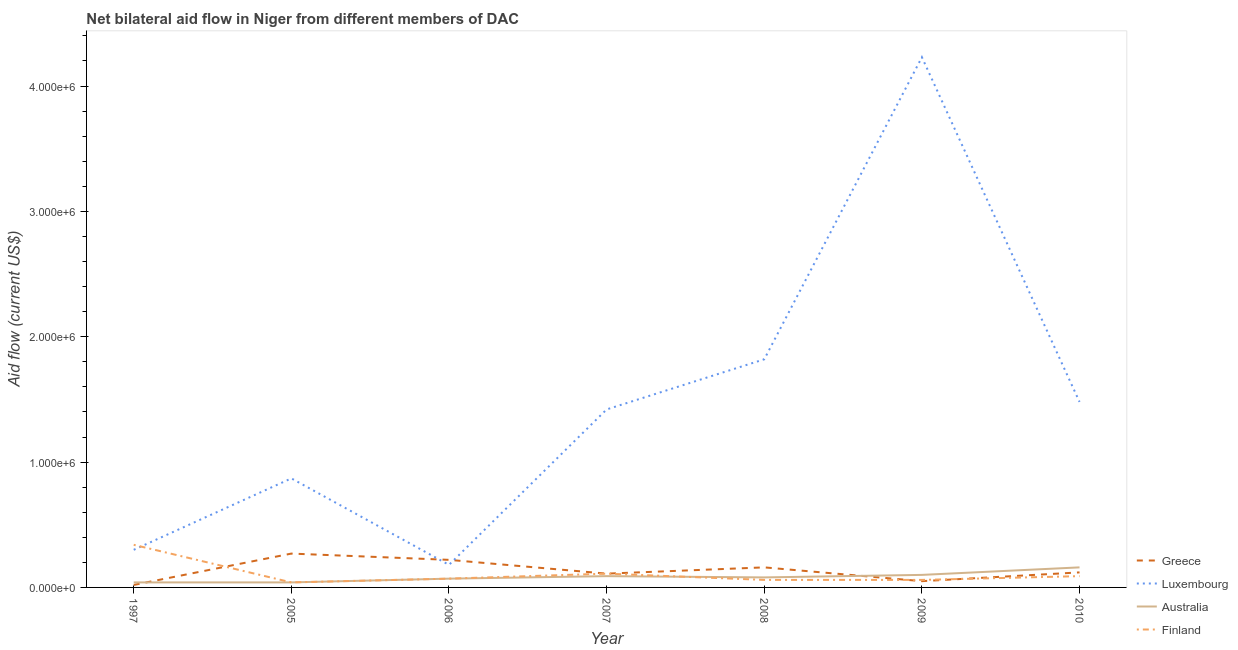How many different coloured lines are there?
Your answer should be very brief. 4. Does the line corresponding to amount of aid given by luxembourg intersect with the line corresponding to amount of aid given by greece?
Ensure brevity in your answer.  Yes. What is the amount of aid given by australia in 2005?
Keep it short and to the point. 4.00e+04. Across all years, what is the maximum amount of aid given by finland?
Your answer should be compact. 3.40e+05. Across all years, what is the minimum amount of aid given by australia?
Ensure brevity in your answer.  4.00e+04. In which year was the amount of aid given by luxembourg minimum?
Offer a terse response. 2006. What is the total amount of aid given by luxembourg in the graph?
Your response must be concise. 1.03e+07. What is the difference between the amount of aid given by luxembourg in 2005 and that in 2010?
Provide a short and direct response. -6.10e+05. What is the difference between the amount of aid given by australia in 2007 and the amount of aid given by finland in 2005?
Ensure brevity in your answer.  5.00e+04. What is the average amount of aid given by greece per year?
Ensure brevity in your answer.  1.36e+05. In the year 2010, what is the difference between the amount of aid given by luxembourg and amount of aid given by greece?
Your answer should be compact. 1.36e+06. In how many years, is the amount of aid given by luxembourg greater than 2400000 US$?
Provide a short and direct response. 1. What is the ratio of the amount of aid given by finland in 2007 to that in 2008?
Give a very brief answer. 1.83. Is the amount of aid given by greece in 2008 less than that in 2010?
Ensure brevity in your answer.  No. What is the difference between the highest and the lowest amount of aid given by australia?
Make the answer very short. 1.20e+05. In how many years, is the amount of aid given by greece greater than the average amount of aid given by greece taken over all years?
Offer a terse response. 3. Is the sum of the amount of aid given by luxembourg in 2006 and 2008 greater than the maximum amount of aid given by australia across all years?
Provide a short and direct response. Yes. Is it the case that in every year, the sum of the amount of aid given by greece and amount of aid given by luxembourg is greater than the amount of aid given by australia?
Your response must be concise. Yes. Is the amount of aid given by australia strictly greater than the amount of aid given by finland over the years?
Give a very brief answer. No. How many years are there in the graph?
Give a very brief answer. 7. What is the difference between two consecutive major ticks on the Y-axis?
Give a very brief answer. 1.00e+06. How are the legend labels stacked?
Your answer should be compact. Vertical. What is the title of the graph?
Provide a short and direct response. Net bilateral aid flow in Niger from different members of DAC. Does "Greece" appear as one of the legend labels in the graph?
Give a very brief answer. Yes. What is the Aid flow (current US$) in Luxembourg in 1997?
Give a very brief answer. 3.00e+05. What is the Aid flow (current US$) in Greece in 2005?
Your answer should be very brief. 2.70e+05. What is the Aid flow (current US$) in Luxembourg in 2005?
Keep it short and to the point. 8.70e+05. What is the Aid flow (current US$) of Australia in 2005?
Give a very brief answer. 4.00e+04. What is the Aid flow (current US$) of Australia in 2006?
Offer a terse response. 7.00e+04. What is the Aid flow (current US$) in Finland in 2006?
Ensure brevity in your answer.  7.00e+04. What is the Aid flow (current US$) in Greece in 2007?
Offer a very short reply. 1.10e+05. What is the Aid flow (current US$) in Luxembourg in 2007?
Provide a short and direct response. 1.42e+06. What is the Aid flow (current US$) in Greece in 2008?
Keep it short and to the point. 1.60e+05. What is the Aid flow (current US$) in Luxembourg in 2008?
Keep it short and to the point. 1.82e+06. What is the Aid flow (current US$) of Australia in 2008?
Keep it short and to the point. 8.00e+04. What is the Aid flow (current US$) in Finland in 2008?
Your response must be concise. 6.00e+04. What is the Aid flow (current US$) in Greece in 2009?
Give a very brief answer. 5.00e+04. What is the Aid flow (current US$) in Luxembourg in 2009?
Provide a succinct answer. 4.23e+06. What is the Aid flow (current US$) in Australia in 2009?
Your response must be concise. 1.00e+05. What is the Aid flow (current US$) of Finland in 2009?
Offer a terse response. 6.00e+04. What is the Aid flow (current US$) of Greece in 2010?
Give a very brief answer. 1.20e+05. What is the Aid flow (current US$) of Luxembourg in 2010?
Offer a terse response. 1.48e+06. Across all years, what is the maximum Aid flow (current US$) of Greece?
Your answer should be very brief. 2.70e+05. Across all years, what is the maximum Aid flow (current US$) of Luxembourg?
Your response must be concise. 4.23e+06. Across all years, what is the maximum Aid flow (current US$) in Australia?
Ensure brevity in your answer.  1.60e+05. Across all years, what is the minimum Aid flow (current US$) of Luxembourg?
Keep it short and to the point. 1.80e+05. What is the total Aid flow (current US$) in Greece in the graph?
Make the answer very short. 9.50e+05. What is the total Aid flow (current US$) of Luxembourg in the graph?
Your response must be concise. 1.03e+07. What is the total Aid flow (current US$) of Australia in the graph?
Ensure brevity in your answer.  5.80e+05. What is the total Aid flow (current US$) in Finland in the graph?
Give a very brief answer. 7.70e+05. What is the difference between the Aid flow (current US$) in Luxembourg in 1997 and that in 2005?
Make the answer very short. -5.70e+05. What is the difference between the Aid flow (current US$) of Australia in 1997 and that in 2005?
Give a very brief answer. 0. What is the difference between the Aid flow (current US$) in Finland in 1997 and that in 2005?
Offer a terse response. 3.00e+05. What is the difference between the Aid flow (current US$) in Australia in 1997 and that in 2006?
Offer a very short reply. -3.00e+04. What is the difference between the Aid flow (current US$) in Finland in 1997 and that in 2006?
Offer a very short reply. 2.70e+05. What is the difference between the Aid flow (current US$) of Greece in 1997 and that in 2007?
Your response must be concise. -9.00e+04. What is the difference between the Aid flow (current US$) of Luxembourg in 1997 and that in 2007?
Offer a terse response. -1.12e+06. What is the difference between the Aid flow (current US$) in Finland in 1997 and that in 2007?
Offer a very short reply. 2.30e+05. What is the difference between the Aid flow (current US$) of Greece in 1997 and that in 2008?
Provide a succinct answer. -1.40e+05. What is the difference between the Aid flow (current US$) in Luxembourg in 1997 and that in 2008?
Give a very brief answer. -1.52e+06. What is the difference between the Aid flow (current US$) of Australia in 1997 and that in 2008?
Your response must be concise. -4.00e+04. What is the difference between the Aid flow (current US$) in Finland in 1997 and that in 2008?
Give a very brief answer. 2.80e+05. What is the difference between the Aid flow (current US$) of Greece in 1997 and that in 2009?
Offer a very short reply. -3.00e+04. What is the difference between the Aid flow (current US$) in Luxembourg in 1997 and that in 2009?
Provide a succinct answer. -3.93e+06. What is the difference between the Aid flow (current US$) of Australia in 1997 and that in 2009?
Offer a terse response. -6.00e+04. What is the difference between the Aid flow (current US$) in Finland in 1997 and that in 2009?
Your answer should be compact. 2.80e+05. What is the difference between the Aid flow (current US$) in Greece in 1997 and that in 2010?
Offer a terse response. -1.00e+05. What is the difference between the Aid flow (current US$) of Luxembourg in 1997 and that in 2010?
Your answer should be very brief. -1.18e+06. What is the difference between the Aid flow (current US$) of Greece in 2005 and that in 2006?
Your response must be concise. 5.00e+04. What is the difference between the Aid flow (current US$) in Luxembourg in 2005 and that in 2006?
Your response must be concise. 6.90e+05. What is the difference between the Aid flow (current US$) in Luxembourg in 2005 and that in 2007?
Offer a very short reply. -5.50e+05. What is the difference between the Aid flow (current US$) in Greece in 2005 and that in 2008?
Make the answer very short. 1.10e+05. What is the difference between the Aid flow (current US$) of Luxembourg in 2005 and that in 2008?
Provide a short and direct response. -9.50e+05. What is the difference between the Aid flow (current US$) in Greece in 2005 and that in 2009?
Keep it short and to the point. 2.20e+05. What is the difference between the Aid flow (current US$) in Luxembourg in 2005 and that in 2009?
Provide a short and direct response. -3.36e+06. What is the difference between the Aid flow (current US$) of Greece in 2005 and that in 2010?
Give a very brief answer. 1.50e+05. What is the difference between the Aid flow (current US$) of Luxembourg in 2005 and that in 2010?
Offer a terse response. -6.10e+05. What is the difference between the Aid flow (current US$) in Luxembourg in 2006 and that in 2007?
Your answer should be compact. -1.24e+06. What is the difference between the Aid flow (current US$) in Australia in 2006 and that in 2007?
Provide a succinct answer. -2.00e+04. What is the difference between the Aid flow (current US$) in Luxembourg in 2006 and that in 2008?
Your answer should be very brief. -1.64e+06. What is the difference between the Aid flow (current US$) in Finland in 2006 and that in 2008?
Your response must be concise. 10000. What is the difference between the Aid flow (current US$) in Greece in 2006 and that in 2009?
Make the answer very short. 1.70e+05. What is the difference between the Aid flow (current US$) in Luxembourg in 2006 and that in 2009?
Give a very brief answer. -4.05e+06. What is the difference between the Aid flow (current US$) in Finland in 2006 and that in 2009?
Give a very brief answer. 10000. What is the difference between the Aid flow (current US$) of Greece in 2006 and that in 2010?
Make the answer very short. 1.00e+05. What is the difference between the Aid flow (current US$) in Luxembourg in 2006 and that in 2010?
Provide a short and direct response. -1.30e+06. What is the difference between the Aid flow (current US$) of Finland in 2006 and that in 2010?
Your response must be concise. -2.00e+04. What is the difference between the Aid flow (current US$) of Greece in 2007 and that in 2008?
Ensure brevity in your answer.  -5.00e+04. What is the difference between the Aid flow (current US$) of Luxembourg in 2007 and that in 2008?
Offer a terse response. -4.00e+05. What is the difference between the Aid flow (current US$) of Australia in 2007 and that in 2008?
Keep it short and to the point. 10000. What is the difference between the Aid flow (current US$) in Luxembourg in 2007 and that in 2009?
Ensure brevity in your answer.  -2.81e+06. What is the difference between the Aid flow (current US$) in Australia in 2007 and that in 2009?
Your answer should be compact. -10000. What is the difference between the Aid flow (current US$) of Greece in 2007 and that in 2010?
Your response must be concise. -10000. What is the difference between the Aid flow (current US$) in Luxembourg in 2007 and that in 2010?
Offer a very short reply. -6.00e+04. What is the difference between the Aid flow (current US$) of Luxembourg in 2008 and that in 2009?
Provide a succinct answer. -2.41e+06. What is the difference between the Aid flow (current US$) of Australia in 2008 and that in 2009?
Make the answer very short. -2.00e+04. What is the difference between the Aid flow (current US$) in Finland in 2008 and that in 2009?
Your answer should be compact. 0. What is the difference between the Aid flow (current US$) in Luxembourg in 2008 and that in 2010?
Your answer should be very brief. 3.40e+05. What is the difference between the Aid flow (current US$) in Finland in 2008 and that in 2010?
Your answer should be very brief. -3.00e+04. What is the difference between the Aid flow (current US$) in Greece in 2009 and that in 2010?
Ensure brevity in your answer.  -7.00e+04. What is the difference between the Aid flow (current US$) of Luxembourg in 2009 and that in 2010?
Your response must be concise. 2.75e+06. What is the difference between the Aid flow (current US$) in Greece in 1997 and the Aid flow (current US$) in Luxembourg in 2005?
Your response must be concise. -8.50e+05. What is the difference between the Aid flow (current US$) in Greece in 1997 and the Aid flow (current US$) in Finland in 2005?
Make the answer very short. -2.00e+04. What is the difference between the Aid flow (current US$) in Luxembourg in 1997 and the Aid flow (current US$) in Finland in 2005?
Make the answer very short. 2.60e+05. What is the difference between the Aid flow (current US$) of Australia in 1997 and the Aid flow (current US$) of Finland in 2005?
Provide a succinct answer. 0. What is the difference between the Aid flow (current US$) in Greece in 1997 and the Aid flow (current US$) in Finland in 2006?
Keep it short and to the point. -5.00e+04. What is the difference between the Aid flow (current US$) in Luxembourg in 1997 and the Aid flow (current US$) in Finland in 2006?
Provide a succinct answer. 2.30e+05. What is the difference between the Aid flow (current US$) of Australia in 1997 and the Aid flow (current US$) of Finland in 2006?
Offer a terse response. -3.00e+04. What is the difference between the Aid flow (current US$) of Greece in 1997 and the Aid flow (current US$) of Luxembourg in 2007?
Provide a succinct answer. -1.40e+06. What is the difference between the Aid flow (current US$) in Greece in 1997 and the Aid flow (current US$) in Finland in 2007?
Keep it short and to the point. -9.00e+04. What is the difference between the Aid flow (current US$) in Australia in 1997 and the Aid flow (current US$) in Finland in 2007?
Provide a short and direct response. -7.00e+04. What is the difference between the Aid flow (current US$) of Greece in 1997 and the Aid flow (current US$) of Luxembourg in 2008?
Ensure brevity in your answer.  -1.80e+06. What is the difference between the Aid flow (current US$) in Greece in 1997 and the Aid flow (current US$) in Australia in 2008?
Give a very brief answer. -6.00e+04. What is the difference between the Aid flow (current US$) in Greece in 1997 and the Aid flow (current US$) in Finland in 2008?
Provide a succinct answer. -4.00e+04. What is the difference between the Aid flow (current US$) of Luxembourg in 1997 and the Aid flow (current US$) of Australia in 2008?
Your response must be concise. 2.20e+05. What is the difference between the Aid flow (current US$) of Luxembourg in 1997 and the Aid flow (current US$) of Finland in 2008?
Give a very brief answer. 2.40e+05. What is the difference between the Aid flow (current US$) in Australia in 1997 and the Aid flow (current US$) in Finland in 2008?
Ensure brevity in your answer.  -2.00e+04. What is the difference between the Aid flow (current US$) of Greece in 1997 and the Aid flow (current US$) of Luxembourg in 2009?
Offer a terse response. -4.21e+06. What is the difference between the Aid flow (current US$) of Luxembourg in 1997 and the Aid flow (current US$) of Finland in 2009?
Make the answer very short. 2.40e+05. What is the difference between the Aid flow (current US$) of Australia in 1997 and the Aid flow (current US$) of Finland in 2009?
Give a very brief answer. -2.00e+04. What is the difference between the Aid flow (current US$) of Greece in 1997 and the Aid flow (current US$) of Luxembourg in 2010?
Your response must be concise. -1.46e+06. What is the difference between the Aid flow (current US$) of Greece in 1997 and the Aid flow (current US$) of Australia in 2010?
Give a very brief answer. -1.40e+05. What is the difference between the Aid flow (current US$) in Luxembourg in 1997 and the Aid flow (current US$) in Australia in 2010?
Your answer should be compact. 1.40e+05. What is the difference between the Aid flow (current US$) of Australia in 1997 and the Aid flow (current US$) of Finland in 2010?
Offer a very short reply. -5.00e+04. What is the difference between the Aid flow (current US$) in Greece in 2005 and the Aid flow (current US$) in Luxembourg in 2006?
Ensure brevity in your answer.  9.00e+04. What is the difference between the Aid flow (current US$) of Greece in 2005 and the Aid flow (current US$) of Luxembourg in 2007?
Your response must be concise. -1.15e+06. What is the difference between the Aid flow (current US$) of Greece in 2005 and the Aid flow (current US$) of Australia in 2007?
Your answer should be very brief. 1.80e+05. What is the difference between the Aid flow (current US$) in Greece in 2005 and the Aid flow (current US$) in Finland in 2007?
Offer a terse response. 1.60e+05. What is the difference between the Aid flow (current US$) of Luxembourg in 2005 and the Aid flow (current US$) of Australia in 2007?
Provide a succinct answer. 7.80e+05. What is the difference between the Aid flow (current US$) of Luxembourg in 2005 and the Aid flow (current US$) of Finland in 2007?
Your response must be concise. 7.60e+05. What is the difference between the Aid flow (current US$) of Greece in 2005 and the Aid flow (current US$) of Luxembourg in 2008?
Offer a very short reply. -1.55e+06. What is the difference between the Aid flow (current US$) in Greece in 2005 and the Aid flow (current US$) in Australia in 2008?
Make the answer very short. 1.90e+05. What is the difference between the Aid flow (current US$) in Luxembourg in 2005 and the Aid flow (current US$) in Australia in 2008?
Ensure brevity in your answer.  7.90e+05. What is the difference between the Aid flow (current US$) of Luxembourg in 2005 and the Aid flow (current US$) of Finland in 2008?
Offer a very short reply. 8.10e+05. What is the difference between the Aid flow (current US$) in Greece in 2005 and the Aid flow (current US$) in Luxembourg in 2009?
Offer a very short reply. -3.96e+06. What is the difference between the Aid flow (current US$) of Greece in 2005 and the Aid flow (current US$) of Australia in 2009?
Make the answer very short. 1.70e+05. What is the difference between the Aid flow (current US$) in Luxembourg in 2005 and the Aid flow (current US$) in Australia in 2009?
Provide a short and direct response. 7.70e+05. What is the difference between the Aid flow (current US$) in Luxembourg in 2005 and the Aid flow (current US$) in Finland in 2009?
Your answer should be very brief. 8.10e+05. What is the difference between the Aid flow (current US$) of Australia in 2005 and the Aid flow (current US$) of Finland in 2009?
Offer a very short reply. -2.00e+04. What is the difference between the Aid flow (current US$) of Greece in 2005 and the Aid flow (current US$) of Luxembourg in 2010?
Offer a terse response. -1.21e+06. What is the difference between the Aid flow (current US$) of Greece in 2005 and the Aid flow (current US$) of Australia in 2010?
Give a very brief answer. 1.10e+05. What is the difference between the Aid flow (current US$) of Greece in 2005 and the Aid flow (current US$) of Finland in 2010?
Offer a very short reply. 1.80e+05. What is the difference between the Aid flow (current US$) of Luxembourg in 2005 and the Aid flow (current US$) of Australia in 2010?
Offer a terse response. 7.10e+05. What is the difference between the Aid flow (current US$) in Luxembourg in 2005 and the Aid flow (current US$) in Finland in 2010?
Keep it short and to the point. 7.80e+05. What is the difference between the Aid flow (current US$) of Australia in 2005 and the Aid flow (current US$) of Finland in 2010?
Offer a very short reply. -5.00e+04. What is the difference between the Aid flow (current US$) in Greece in 2006 and the Aid flow (current US$) in Luxembourg in 2007?
Keep it short and to the point. -1.20e+06. What is the difference between the Aid flow (current US$) of Greece in 2006 and the Aid flow (current US$) of Luxembourg in 2008?
Your answer should be very brief. -1.60e+06. What is the difference between the Aid flow (current US$) of Luxembourg in 2006 and the Aid flow (current US$) of Australia in 2008?
Offer a terse response. 1.00e+05. What is the difference between the Aid flow (current US$) of Australia in 2006 and the Aid flow (current US$) of Finland in 2008?
Make the answer very short. 10000. What is the difference between the Aid flow (current US$) in Greece in 2006 and the Aid flow (current US$) in Luxembourg in 2009?
Ensure brevity in your answer.  -4.01e+06. What is the difference between the Aid flow (current US$) in Greece in 2006 and the Aid flow (current US$) in Australia in 2009?
Ensure brevity in your answer.  1.20e+05. What is the difference between the Aid flow (current US$) of Greece in 2006 and the Aid flow (current US$) of Luxembourg in 2010?
Offer a terse response. -1.26e+06. What is the difference between the Aid flow (current US$) of Greece in 2006 and the Aid flow (current US$) of Finland in 2010?
Your answer should be compact. 1.30e+05. What is the difference between the Aid flow (current US$) in Luxembourg in 2006 and the Aid flow (current US$) in Australia in 2010?
Provide a succinct answer. 2.00e+04. What is the difference between the Aid flow (current US$) of Greece in 2007 and the Aid flow (current US$) of Luxembourg in 2008?
Provide a short and direct response. -1.71e+06. What is the difference between the Aid flow (current US$) of Luxembourg in 2007 and the Aid flow (current US$) of Australia in 2008?
Ensure brevity in your answer.  1.34e+06. What is the difference between the Aid flow (current US$) in Luxembourg in 2007 and the Aid flow (current US$) in Finland in 2008?
Your answer should be compact. 1.36e+06. What is the difference between the Aid flow (current US$) in Australia in 2007 and the Aid flow (current US$) in Finland in 2008?
Provide a short and direct response. 3.00e+04. What is the difference between the Aid flow (current US$) of Greece in 2007 and the Aid flow (current US$) of Luxembourg in 2009?
Ensure brevity in your answer.  -4.12e+06. What is the difference between the Aid flow (current US$) in Greece in 2007 and the Aid flow (current US$) in Finland in 2009?
Your answer should be compact. 5.00e+04. What is the difference between the Aid flow (current US$) of Luxembourg in 2007 and the Aid flow (current US$) of Australia in 2009?
Make the answer very short. 1.32e+06. What is the difference between the Aid flow (current US$) in Luxembourg in 2007 and the Aid flow (current US$) in Finland in 2009?
Keep it short and to the point. 1.36e+06. What is the difference between the Aid flow (current US$) of Greece in 2007 and the Aid flow (current US$) of Luxembourg in 2010?
Keep it short and to the point. -1.37e+06. What is the difference between the Aid flow (current US$) of Greece in 2007 and the Aid flow (current US$) of Australia in 2010?
Provide a short and direct response. -5.00e+04. What is the difference between the Aid flow (current US$) in Greece in 2007 and the Aid flow (current US$) in Finland in 2010?
Offer a terse response. 2.00e+04. What is the difference between the Aid flow (current US$) in Luxembourg in 2007 and the Aid flow (current US$) in Australia in 2010?
Offer a very short reply. 1.26e+06. What is the difference between the Aid flow (current US$) in Luxembourg in 2007 and the Aid flow (current US$) in Finland in 2010?
Your answer should be compact. 1.33e+06. What is the difference between the Aid flow (current US$) of Australia in 2007 and the Aid flow (current US$) of Finland in 2010?
Your response must be concise. 0. What is the difference between the Aid flow (current US$) in Greece in 2008 and the Aid flow (current US$) in Luxembourg in 2009?
Offer a very short reply. -4.07e+06. What is the difference between the Aid flow (current US$) in Greece in 2008 and the Aid flow (current US$) in Finland in 2009?
Offer a terse response. 1.00e+05. What is the difference between the Aid flow (current US$) in Luxembourg in 2008 and the Aid flow (current US$) in Australia in 2009?
Provide a succinct answer. 1.72e+06. What is the difference between the Aid flow (current US$) in Luxembourg in 2008 and the Aid flow (current US$) in Finland in 2009?
Give a very brief answer. 1.76e+06. What is the difference between the Aid flow (current US$) of Australia in 2008 and the Aid flow (current US$) of Finland in 2009?
Provide a succinct answer. 2.00e+04. What is the difference between the Aid flow (current US$) in Greece in 2008 and the Aid flow (current US$) in Luxembourg in 2010?
Your answer should be compact. -1.32e+06. What is the difference between the Aid flow (current US$) of Greece in 2008 and the Aid flow (current US$) of Australia in 2010?
Your answer should be very brief. 0. What is the difference between the Aid flow (current US$) of Greece in 2008 and the Aid flow (current US$) of Finland in 2010?
Ensure brevity in your answer.  7.00e+04. What is the difference between the Aid flow (current US$) of Luxembourg in 2008 and the Aid flow (current US$) of Australia in 2010?
Provide a succinct answer. 1.66e+06. What is the difference between the Aid flow (current US$) of Luxembourg in 2008 and the Aid flow (current US$) of Finland in 2010?
Provide a short and direct response. 1.73e+06. What is the difference between the Aid flow (current US$) in Australia in 2008 and the Aid flow (current US$) in Finland in 2010?
Your answer should be compact. -10000. What is the difference between the Aid flow (current US$) in Greece in 2009 and the Aid flow (current US$) in Luxembourg in 2010?
Ensure brevity in your answer.  -1.43e+06. What is the difference between the Aid flow (current US$) in Greece in 2009 and the Aid flow (current US$) in Australia in 2010?
Give a very brief answer. -1.10e+05. What is the difference between the Aid flow (current US$) of Luxembourg in 2009 and the Aid flow (current US$) of Australia in 2010?
Your answer should be very brief. 4.07e+06. What is the difference between the Aid flow (current US$) in Luxembourg in 2009 and the Aid flow (current US$) in Finland in 2010?
Offer a very short reply. 4.14e+06. What is the difference between the Aid flow (current US$) in Australia in 2009 and the Aid flow (current US$) in Finland in 2010?
Ensure brevity in your answer.  10000. What is the average Aid flow (current US$) of Greece per year?
Your answer should be compact. 1.36e+05. What is the average Aid flow (current US$) in Luxembourg per year?
Ensure brevity in your answer.  1.47e+06. What is the average Aid flow (current US$) in Australia per year?
Your answer should be very brief. 8.29e+04. What is the average Aid flow (current US$) of Finland per year?
Your answer should be very brief. 1.10e+05. In the year 1997, what is the difference between the Aid flow (current US$) of Greece and Aid flow (current US$) of Luxembourg?
Keep it short and to the point. -2.80e+05. In the year 1997, what is the difference between the Aid flow (current US$) of Greece and Aid flow (current US$) of Australia?
Offer a very short reply. -2.00e+04. In the year 1997, what is the difference between the Aid flow (current US$) in Greece and Aid flow (current US$) in Finland?
Provide a succinct answer. -3.20e+05. In the year 2005, what is the difference between the Aid flow (current US$) of Greece and Aid flow (current US$) of Luxembourg?
Provide a short and direct response. -6.00e+05. In the year 2005, what is the difference between the Aid flow (current US$) in Greece and Aid flow (current US$) in Australia?
Offer a terse response. 2.30e+05. In the year 2005, what is the difference between the Aid flow (current US$) of Greece and Aid flow (current US$) of Finland?
Give a very brief answer. 2.30e+05. In the year 2005, what is the difference between the Aid flow (current US$) of Luxembourg and Aid flow (current US$) of Australia?
Your answer should be compact. 8.30e+05. In the year 2005, what is the difference between the Aid flow (current US$) of Luxembourg and Aid flow (current US$) of Finland?
Provide a succinct answer. 8.30e+05. In the year 2005, what is the difference between the Aid flow (current US$) in Australia and Aid flow (current US$) in Finland?
Provide a short and direct response. 0. In the year 2006, what is the difference between the Aid flow (current US$) in Greece and Aid flow (current US$) in Luxembourg?
Give a very brief answer. 4.00e+04. In the year 2006, what is the difference between the Aid flow (current US$) of Greece and Aid flow (current US$) of Australia?
Offer a terse response. 1.50e+05. In the year 2007, what is the difference between the Aid flow (current US$) of Greece and Aid flow (current US$) of Luxembourg?
Offer a terse response. -1.31e+06. In the year 2007, what is the difference between the Aid flow (current US$) in Greece and Aid flow (current US$) in Australia?
Offer a very short reply. 2.00e+04. In the year 2007, what is the difference between the Aid flow (current US$) in Greece and Aid flow (current US$) in Finland?
Offer a terse response. 0. In the year 2007, what is the difference between the Aid flow (current US$) in Luxembourg and Aid flow (current US$) in Australia?
Offer a terse response. 1.33e+06. In the year 2007, what is the difference between the Aid flow (current US$) in Luxembourg and Aid flow (current US$) in Finland?
Provide a succinct answer. 1.31e+06. In the year 2007, what is the difference between the Aid flow (current US$) in Australia and Aid flow (current US$) in Finland?
Your response must be concise. -2.00e+04. In the year 2008, what is the difference between the Aid flow (current US$) of Greece and Aid flow (current US$) of Luxembourg?
Your answer should be very brief. -1.66e+06. In the year 2008, what is the difference between the Aid flow (current US$) of Greece and Aid flow (current US$) of Australia?
Keep it short and to the point. 8.00e+04. In the year 2008, what is the difference between the Aid flow (current US$) of Greece and Aid flow (current US$) of Finland?
Keep it short and to the point. 1.00e+05. In the year 2008, what is the difference between the Aid flow (current US$) in Luxembourg and Aid flow (current US$) in Australia?
Your response must be concise. 1.74e+06. In the year 2008, what is the difference between the Aid flow (current US$) of Luxembourg and Aid flow (current US$) of Finland?
Make the answer very short. 1.76e+06. In the year 2009, what is the difference between the Aid flow (current US$) in Greece and Aid flow (current US$) in Luxembourg?
Ensure brevity in your answer.  -4.18e+06. In the year 2009, what is the difference between the Aid flow (current US$) in Luxembourg and Aid flow (current US$) in Australia?
Your answer should be compact. 4.13e+06. In the year 2009, what is the difference between the Aid flow (current US$) of Luxembourg and Aid flow (current US$) of Finland?
Your answer should be compact. 4.17e+06. In the year 2010, what is the difference between the Aid flow (current US$) in Greece and Aid flow (current US$) in Luxembourg?
Your response must be concise. -1.36e+06. In the year 2010, what is the difference between the Aid flow (current US$) in Greece and Aid flow (current US$) in Finland?
Offer a very short reply. 3.00e+04. In the year 2010, what is the difference between the Aid flow (current US$) in Luxembourg and Aid flow (current US$) in Australia?
Offer a terse response. 1.32e+06. In the year 2010, what is the difference between the Aid flow (current US$) of Luxembourg and Aid flow (current US$) of Finland?
Offer a terse response. 1.39e+06. What is the ratio of the Aid flow (current US$) of Greece in 1997 to that in 2005?
Your response must be concise. 0.07. What is the ratio of the Aid flow (current US$) in Luxembourg in 1997 to that in 2005?
Make the answer very short. 0.34. What is the ratio of the Aid flow (current US$) in Finland in 1997 to that in 2005?
Ensure brevity in your answer.  8.5. What is the ratio of the Aid flow (current US$) in Greece in 1997 to that in 2006?
Provide a succinct answer. 0.09. What is the ratio of the Aid flow (current US$) in Luxembourg in 1997 to that in 2006?
Your response must be concise. 1.67. What is the ratio of the Aid flow (current US$) of Finland in 1997 to that in 2006?
Keep it short and to the point. 4.86. What is the ratio of the Aid flow (current US$) of Greece in 1997 to that in 2007?
Your response must be concise. 0.18. What is the ratio of the Aid flow (current US$) in Luxembourg in 1997 to that in 2007?
Your response must be concise. 0.21. What is the ratio of the Aid flow (current US$) of Australia in 1997 to that in 2007?
Offer a very short reply. 0.44. What is the ratio of the Aid flow (current US$) in Finland in 1997 to that in 2007?
Keep it short and to the point. 3.09. What is the ratio of the Aid flow (current US$) of Greece in 1997 to that in 2008?
Your answer should be compact. 0.12. What is the ratio of the Aid flow (current US$) in Luxembourg in 1997 to that in 2008?
Ensure brevity in your answer.  0.16. What is the ratio of the Aid flow (current US$) in Finland in 1997 to that in 2008?
Provide a short and direct response. 5.67. What is the ratio of the Aid flow (current US$) of Greece in 1997 to that in 2009?
Provide a succinct answer. 0.4. What is the ratio of the Aid flow (current US$) of Luxembourg in 1997 to that in 2009?
Give a very brief answer. 0.07. What is the ratio of the Aid flow (current US$) of Australia in 1997 to that in 2009?
Your answer should be compact. 0.4. What is the ratio of the Aid flow (current US$) in Finland in 1997 to that in 2009?
Your answer should be very brief. 5.67. What is the ratio of the Aid flow (current US$) of Greece in 1997 to that in 2010?
Provide a short and direct response. 0.17. What is the ratio of the Aid flow (current US$) in Luxembourg in 1997 to that in 2010?
Your response must be concise. 0.2. What is the ratio of the Aid flow (current US$) of Finland in 1997 to that in 2010?
Keep it short and to the point. 3.78. What is the ratio of the Aid flow (current US$) of Greece in 2005 to that in 2006?
Your answer should be very brief. 1.23. What is the ratio of the Aid flow (current US$) of Luxembourg in 2005 to that in 2006?
Keep it short and to the point. 4.83. What is the ratio of the Aid flow (current US$) of Finland in 2005 to that in 2006?
Keep it short and to the point. 0.57. What is the ratio of the Aid flow (current US$) in Greece in 2005 to that in 2007?
Give a very brief answer. 2.45. What is the ratio of the Aid flow (current US$) of Luxembourg in 2005 to that in 2007?
Give a very brief answer. 0.61. What is the ratio of the Aid flow (current US$) of Australia in 2005 to that in 2007?
Give a very brief answer. 0.44. What is the ratio of the Aid flow (current US$) of Finland in 2005 to that in 2007?
Give a very brief answer. 0.36. What is the ratio of the Aid flow (current US$) in Greece in 2005 to that in 2008?
Your response must be concise. 1.69. What is the ratio of the Aid flow (current US$) in Luxembourg in 2005 to that in 2008?
Your answer should be very brief. 0.48. What is the ratio of the Aid flow (current US$) in Finland in 2005 to that in 2008?
Make the answer very short. 0.67. What is the ratio of the Aid flow (current US$) in Luxembourg in 2005 to that in 2009?
Ensure brevity in your answer.  0.21. What is the ratio of the Aid flow (current US$) of Australia in 2005 to that in 2009?
Give a very brief answer. 0.4. What is the ratio of the Aid flow (current US$) of Greece in 2005 to that in 2010?
Ensure brevity in your answer.  2.25. What is the ratio of the Aid flow (current US$) of Luxembourg in 2005 to that in 2010?
Keep it short and to the point. 0.59. What is the ratio of the Aid flow (current US$) in Finland in 2005 to that in 2010?
Offer a very short reply. 0.44. What is the ratio of the Aid flow (current US$) in Luxembourg in 2006 to that in 2007?
Ensure brevity in your answer.  0.13. What is the ratio of the Aid flow (current US$) in Finland in 2006 to that in 2007?
Provide a succinct answer. 0.64. What is the ratio of the Aid flow (current US$) in Greece in 2006 to that in 2008?
Your response must be concise. 1.38. What is the ratio of the Aid flow (current US$) in Luxembourg in 2006 to that in 2008?
Offer a very short reply. 0.1. What is the ratio of the Aid flow (current US$) of Finland in 2006 to that in 2008?
Give a very brief answer. 1.17. What is the ratio of the Aid flow (current US$) of Luxembourg in 2006 to that in 2009?
Offer a terse response. 0.04. What is the ratio of the Aid flow (current US$) of Finland in 2006 to that in 2009?
Ensure brevity in your answer.  1.17. What is the ratio of the Aid flow (current US$) in Greece in 2006 to that in 2010?
Provide a succinct answer. 1.83. What is the ratio of the Aid flow (current US$) of Luxembourg in 2006 to that in 2010?
Your answer should be very brief. 0.12. What is the ratio of the Aid flow (current US$) in Australia in 2006 to that in 2010?
Your response must be concise. 0.44. What is the ratio of the Aid flow (current US$) in Finland in 2006 to that in 2010?
Provide a short and direct response. 0.78. What is the ratio of the Aid flow (current US$) of Greece in 2007 to that in 2008?
Offer a very short reply. 0.69. What is the ratio of the Aid flow (current US$) of Luxembourg in 2007 to that in 2008?
Provide a short and direct response. 0.78. What is the ratio of the Aid flow (current US$) of Australia in 2007 to that in 2008?
Ensure brevity in your answer.  1.12. What is the ratio of the Aid flow (current US$) in Finland in 2007 to that in 2008?
Your response must be concise. 1.83. What is the ratio of the Aid flow (current US$) of Luxembourg in 2007 to that in 2009?
Give a very brief answer. 0.34. What is the ratio of the Aid flow (current US$) of Australia in 2007 to that in 2009?
Offer a very short reply. 0.9. What is the ratio of the Aid flow (current US$) in Finland in 2007 to that in 2009?
Ensure brevity in your answer.  1.83. What is the ratio of the Aid flow (current US$) of Greece in 2007 to that in 2010?
Offer a terse response. 0.92. What is the ratio of the Aid flow (current US$) of Luxembourg in 2007 to that in 2010?
Offer a very short reply. 0.96. What is the ratio of the Aid flow (current US$) in Australia in 2007 to that in 2010?
Make the answer very short. 0.56. What is the ratio of the Aid flow (current US$) of Finland in 2007 to that in 2010?
Ensure brevity in your answer.  1.22. What is the ratio of the Aid flow (current US$) in Greece in 2008 to that in 2009?
Ensure brevity in your answer.  3.2. What is the ratio of the Aid flow (current US$) in Luxembourg in 2008 to that in 2009?
Give a very brief answer. 0.43. What is the ratio of the Aid flow (current US$) in Australia in 2008 to that in 2009?
Provide a succinct answer. 0.8. What is the ratio of the Aid flow (current US$) of Finland in 2008 to that in 2009?
Provide a short and direct response. 1. What is the ratio of the Aid flow (current US$) of Luxembourg in 2008 to that in 2010?
Provide a short and direct response. 1.23. What is the ratio of the Aid flow (current US$) in Finland in 2008 to that in 2010?
Your answer should be very brief. 0.67. What is the ratio of the Aid flow (current US$) of Greece in 2009 to that in 2010?
Your answer should be very brief. 0.42. What is the ratio of the Aid flow (current US$) of Luxembourg in 2009 to that in 2010?
Provide a succinct answer. 2.86. What is the ratio of the Aid flow (current US$) in Finland in 2009 to that in 2010?
Your response must be concise. 0.67. What is the difference between the highest and the second highest Aid flow (current US$) of Luxembourg?
Give a very brief answer. 2.41e+06. What is the difference between the highest and the lowest Aid flow (current US$) in Luxembourg?
Your answer should be compact. 4.05e+06. 